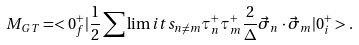<formula> <loc_0><loc_0><loc_500><loc_500>M _ { G T } = < 0 ^ { + } _ { f } | \frac { 1 } { 2 } \sum \lim i t s _ { n \ne m } \tau ^ { + } _ { n } \tau ^ { + } _ { m } \frac { 2 } { \Delta } \vec { \sigma } _ { n } \cdot \vec { \sigma } _ { m } | 0 ^ { + } _ { i } > .</formula> 